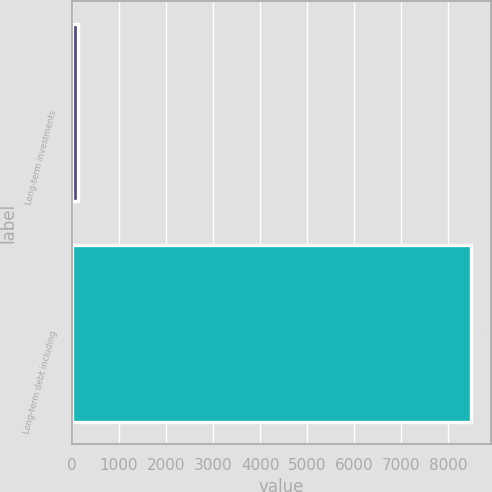Convert chart. <chart><loc_0><loc_0><loc_500><loc_500><bar_chart><fcel>Long-term investments<fcel>Long-term debt including<nl><fcel>139<fcel>8482<nl></chart> 